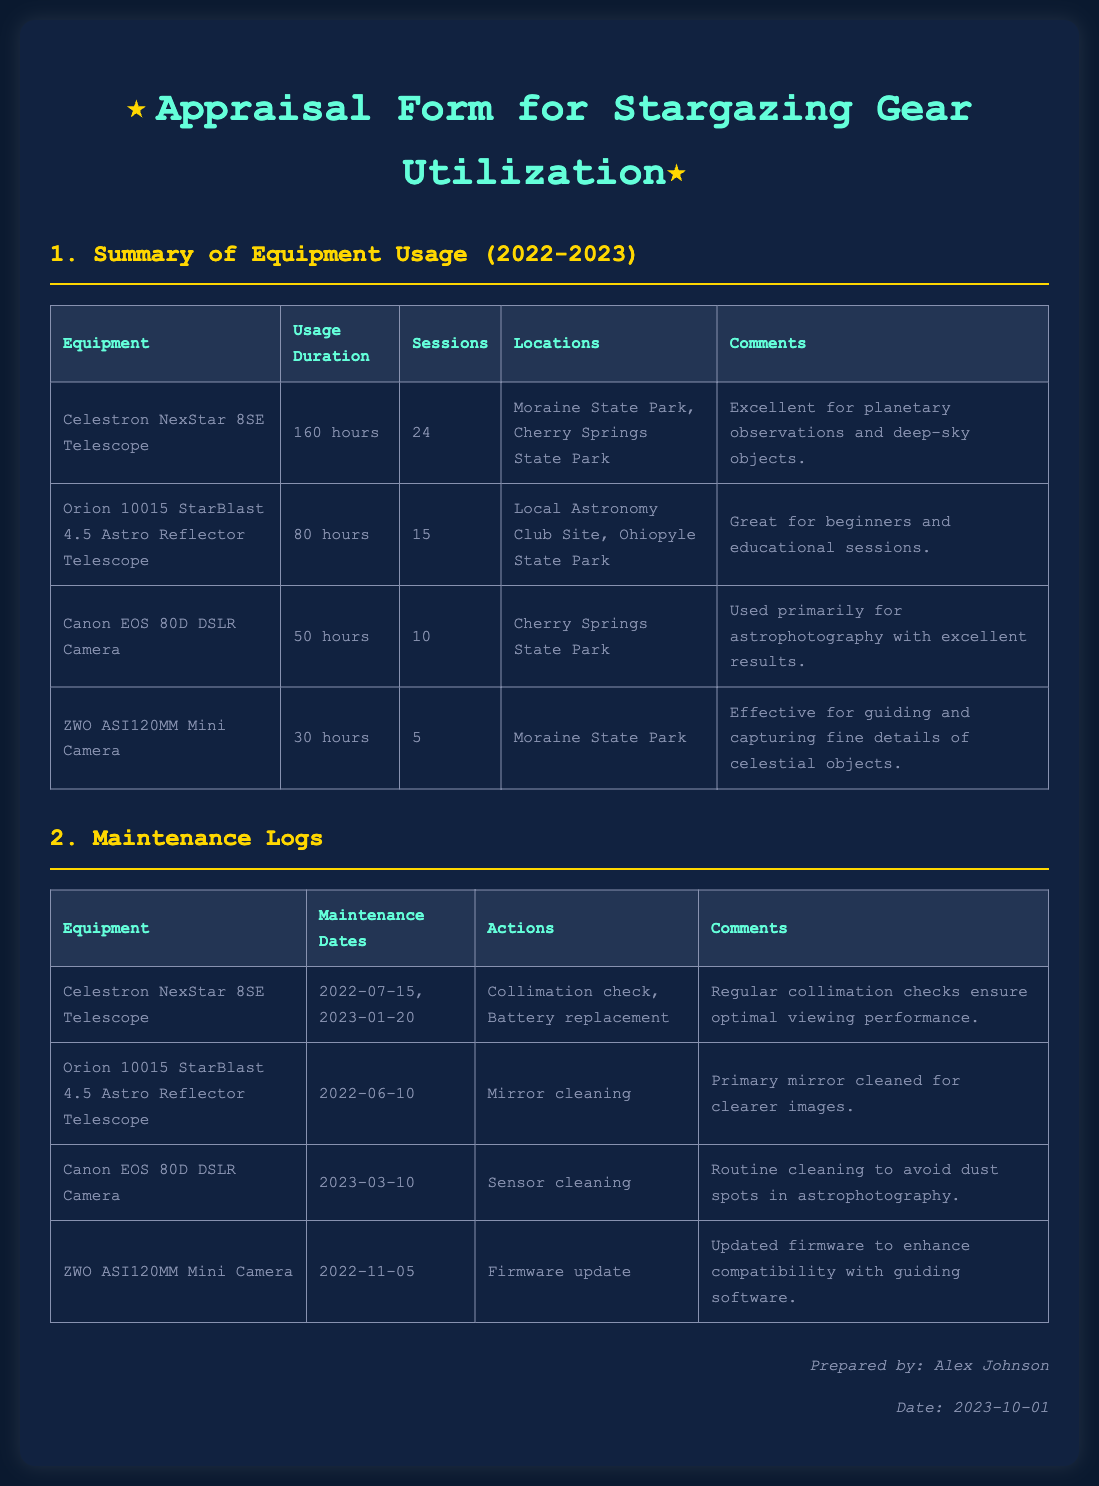What is the total usage duration of the Celestron NexStar 8SE Telescope? The total usage duration is found in the summary of equipment usage, specifically for the Celestron NexStar 8SE Telescope, which is stated as 160 hours.
Answer: 160 hours How many sessions were held with the Orion 10015 StarBlast 4.5 Astro Reflector Telescope? The number of sessions is listed in the summary of equipment usage under the Orion 10015 StarBlast 4.5 Astro Reflector Telescope, which indicates 15 sessions.
Answer: 15 sessions What is the last maintenance date for the Canon EOS 80D DSLR Camera? The last maintenance date can be found in the maintenance logs under the Canon EOS 80D DSLR Camera, recorded as 2023-03-10.
Answer: 2023-03-10 How many sessions did the ZWO ASI120MM Mini Camera have? The number of sessions is included in the usage summary for the ZWO ASI120MM Mini Camera, which shows 5 sessions.
Answer: 5 sessions What action was performed on the Celestron NexStar 8SE Telescope during maintenance? Maintenance actions for the Celestron NexStar 8SE Telescope include collimation check and battery replacement, as stated in the maintenance logs.
Answer: Collimation check, Battery replacement Which telescope was noted for its effectiveness for guiding and capturing fine details? The ZWO ASI120MM Mini Camera is noted for being effective for guiding and capturing fine details, as indicated in the equipment usage summary.
Answer: ZWO ASI120MM Mini Camera Which location was used for astrophotography with the Canon EOS 80D? The location used for astrophotography with the Canon EOS 80D DSLR Camera is specifically noted as Cherry Springs State Park in the usage summary.
Answer: Cherry Springs State Park What was primarily cleaned on the Orion 10015 StarBlast 4.5 Astro Reflector Telescope? The primary maintenance action on the Orion 10015 StarBlast 4.5 Astro Reflector Telescope included mirror cleaning, as documented in the maintenance logs.
Answer: Mirror cleaning 